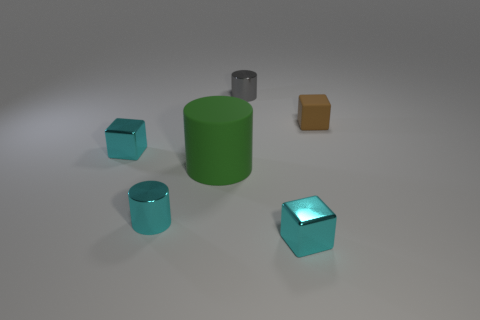There is another small metal thing that is the same shape as the gray metallic object; what color is it?
Provide a short and direct response. Cyan. Are any green matte objects visible?
Provide a succinct answer. Yes. Is the material of the thing behind the tiny brown matte thing the same as the tiny brown object behind the large matte cylinder?
Provide a short and direct response. No. What number of objects are either small metallic cylinders to the left of the green thing or tiny blocks in front of the brown cube?
Offer a very short reply. 3. There is a tiny metal block that is behind the green cylinder; does it have the same color as the metal cylinder that is in front of the tiny brown block?
Provide a succinct answer. Yes. There is a metal thing that is in front of the large green rubber object and to the left of the gray object; what is its shape?
Your answer should be compact. Cylinder. What is the color of the other cylinder that is the same size as the gray cylinder?
Offer a terse response. Cyan. There is a cyan metallic cube that is to the right of the gray metal cylinder; does it have the same size as the cyan shiny block behind the big green thing?
Offer a terse response. Yes. There is a block that is behind the large green cylinder and right of the big green rubber cylinder; what material is it made of?
Give a very brief answer. Rubber. What number of other objects are there of the same size as the green thing?
Give a very brief answer. 0. 